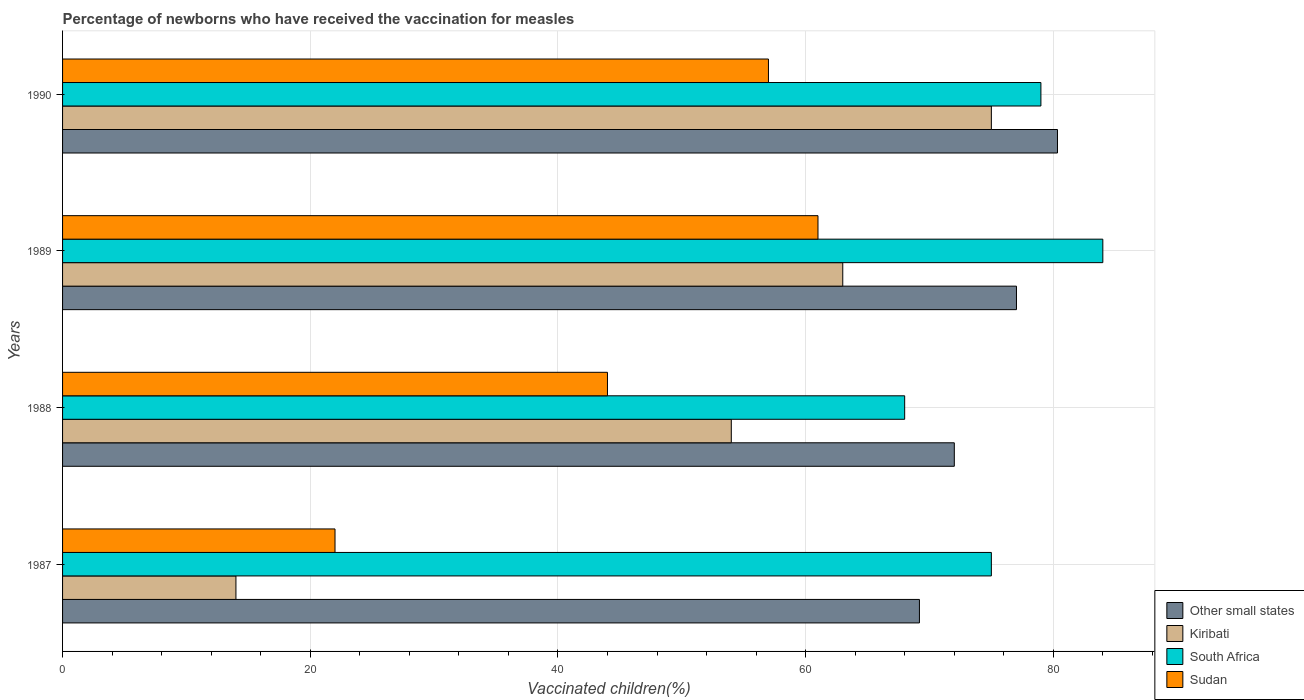How many different coloured bars are there?
Provide a short and direct response. 4. How many groups of bars are there?
Ensure brevity in your answer.  4. Are the number of bars per tick equal to the number of legend labels?
Ensure brevity in your answer.  Yes. Are the number of bars on each tick of the Y-axis equal?
Provide a short and direct response. Yes. How many bars are there on the 4th tick from the top?
Your answer should be compact. 4. How many bars are there on the 3rd tick from the bottom?
Your answer should be compact. 4. In how many cases, is the number of bars for a given year not equal to the number of legend labels?
Give a very brief answer. 0. In which year was the percentage of vaccinated children in Kiribati maximum?
Make the answer very short. 1990. In which year was the percentage of vaccinated children in Sudan minimum?
Your answer should be compact. 1987. What is the total percentage of vaccinated children in South Africa in the graph?
Ensure brevity in your answer.  306. What is the difference between the percentage of vaccinated children in Other small states in 1989 and that in 1990?
Your answer should be compact. -3.31. What is the difference between the percentage of vaccinated children in Kiribati in 1990 and the percentage of vaccinated children in Other small states in 1989?
Your response must be concise. -2.03. What is the ratio of the percentage of vaccinated children in Kiribati in 1987 to that in 1988?
Keep it short and to the point. 0.26. Is the difference between the percentage of vaccinated children in Sudan in 1988 and 1990 greater than the difference between the percentage of vaccinated children in South Africa in 1988 and 1990?
Make the answer very short. No. In how many years, is the percentage of vaccinated children in Other small states greater than the average percentage of vaccinated children in Other small states taken over all years?
Ensure brevity in your answer.  2. Is the sum of the percentage of vaccinated children in Other small states in 1989 and 1990 greater than the maximum percentage of vaccinated children in Kiribati across all years?
Provide a short and direct response. Yes. Is it the case that in every year, the sum of the percentage of vaccinated children in Kiribati and percentage of vaccinated children in Sudan is greater than the sum of percentage of vaccinated children in South Africa and percentage of vaccinated children in Other small states?
Your answer should be very brief. No. What does the 2nd bar from the top in 1990 represents?
Make the answer very short. South Africa. What does the 4th bar from the bottom in 1989 represents?
Your answer should be very brief. Sudan. Is it the case that in every year, the sum of the percentage of vaccinated children in Sudan and percentage of vaccinated children in Kiribati is greater than the percentage of vaccinated children in Other small states?
Your response must be concise. No. How many years are there in the graph?
Provide a succinct answer. 4. What is the difference between two consecutive major ticks on the X-axis?
Provide a short and direct response. 20. Are the values on the major ticks of X-axis written in scientific E-notation?
Your answer should be compact. No. Does the graph contain any zero values?
Your answer should be very brief. No. Does the graph contain grids?
Offer a very short reply. Yes. Where does the legend appear in the graph?
Provide a succinct answer. Bottom right. How many legend labels are there?
Keep it short and to the point. 4. What is the title of the graph?
Provide a succinct answer. Percentage of newborns who have received the vaccination for measles. What is the label or title of the X-axis?
Offer a very short reply. Vaccinated children(%). What is the label or title of the Y-axis?
Offer a terse response. Years. What is the Vaccinated children(%) of Other small states in 1987?
Keep it short and to the point. 69.19. What is the Vaccinated children(%) of Sudan in 1987?
Offer a terse response. 22. What is the Vaccinated children(%) in Other small states in 1988?
Offer a very short reply. 72.01. What is the Vaccinated children(%) in Kiribati in 1988?
Offer a terse response. 54. What is the Vaccinated children(%) in South Africa in 1988?
Provide a succinct answer. 68. What is the Vaccinated children(%) in Sudan in 1988?
Offer a terse response. 44. What is the Vaccinated children(%) in Other small states in 1989?
Make the answer very short. 77.03. What is the Vaccinated children(%) of South Africa in 1989?
Your response must be concise. 84. What is the Vaccinated children(%) of Sudan in 1989?
Provide a succinct answer. 61. What is the Vaccinated children(%) of Other small states in 1990?
Keep it short and to the point. 80.34. What is the Vaccinated children(%) of Kiribati in 1990?
Offer a very short reply. 75. What is the Vaccinated children(%) of South Africa in 1990?
Provide a succinct answer. 79. What is the Vaccinated children(%) in Sudan in 1990?
Provide a succinct answer. 57. Across all years, what is the maximum Vaccinated children(%) of Other small states?
Keep it short and to the point. 80.34. Across all years, what is the minimum Vaccinated children(%) in Other small states?
Offer a terse response. 69.19. Across all years, what is the minimum Vaccinated children(%) of Kiribati?
Ensure brevity in your answer.  14. Across all years, what is the minimum Vaccinated children(%) in South Africa?
Offer a very short reply. 68. What is the total Vaccinated children(%) of Other small states in the graph?
Provide a short and direct response. 298.57. What is the total Vaccinated children(%) in Kiribati in the graph?
Offer a terse response. 206. What is the total Vaccinated children(%) of South Africa in the graph?
Offer a terse response. 306. What is the total Vaccinated children(%) in Sudan in the graph?
Offer a very short reply. 184. What is the difference between the Vaccinated children(%) in Other small states in 1987 and that in 1988?
Your response must be concise. -2.82. What is the difference between the Vaccinated children(%) in Other small states in 1987 and that in 1989?
Keep it short and to the point. -7.84. What is the difference between the Vaccinated children(%) in Kiribati in 1987 and that in 1989?
Your answer should be compact. -49. What is the difference between the Vaccinated children(%) of South Africa in 1987 and that in 1989?
Give a very brief answer. -9. What is the difference between the Vaccinated children(%) in Sudan in 1987 and that in 1989?
Provide a short and direct response. -39. What is the difference between the Vaccinated children(%) of Other small states in 1987 and that in 1990?
Your answer should be very brief. -11.15. What is the difference between the Vaccinated children(%) of Kiribati in 1987 and that in 1990?
Offer a very short reply. -61. What is the difference between the Vaccinated children(%) of South Africa in 1987 and that in 1990?
Ensure brevity in your answer.  -4. What is the difference between the Vaccinated children(%) in Sudan in 1987 and that in 1990?
Your answer should be very brief. -35. What is the difference between the Vaccinated children(%) of Other small states in 1988 and that in 1989?
Your answer should be very brief. -5.02. What is the difference between the Vaccinated children(%) of Sudan in 1988 and that in 1989?
Provide a succinct answer. -17. What is the difference between the Vaccinated children(%) in Other small states in 1988 and that in 1990?
Ensure brevity in your answer.  -8.33. What is the difference between the Vaccinated children(%) in Kiribati in 1988 and that in 1990?
Offer a terse response. -21. What is the difference between the Vaccinated children(%) of South Africa in 1988 and that in 1990?
Ensure brevity in your answer.  -11. What is the difference between the Vaccinated children(%) in Other small states in 1989 and that in 1990?
Your answer should be compact. -3.31. What is the difference between the Vaccinated children(%) in South Africa in 1989 and that in 1990?
Offer a terse response. 5. What is the difference between the Vaccinated children(%) of Other small states in 1987 and the Vaccinated children(%) of Kiribati in 1988?
Make the answer very short. 15.19. What is the difference between the Vaccinated children(%) in Other small states in 1987 and the Vaccinated children(%) in South Africa in 1988?
Give a very brief answer. 1.19. What is the difference between the Vaccinated children(%) in Other small states in 1987 and the Vaccinated children(%) in Sudan in 1988?
Keep it short and to the point. 25.19. What is the difference between the Vaccinated children(%) of Kiribati in 1987 and the Vaccinated children(%) of South Africa in 1988?
Offer a very short reply. -54. What is the difference between the Vaccinated children(%) of Kiribati in 1987 and the Vaccinated children(%) of Sudan in 1988?
Your response must be concise. -30. What is the difference between the Vaccinated children(%) in South Africa in 1987 and the Vaccinated children(%) in Sudan in 1988?
Ensure brevity in your answer.  31. What is the difference between the Vaccinated children(%) in Other small states in 1987 and the Vaccinated children(%) in Kiribati in 1989?
Ensure brevity in your answer.  6.19. What is the difference between the Vaccinated children(%) in Other small states in 1987 and the Vaccinated children(%) in South Africa in 1989?
Ensure brevity in your answer.  -14.81. What is the difference between the Vaccinated children(%) of Other small states in 1987 and the Vaccinated children(%) of Sudan in 1989?
Provide a succinct answer. 8.19. What is the difference between the Vaccinated children(%) in Kiribati in 1987 and the Vaccinated children(%) in South Africa in 1989?
Your response must be concise. -70. What is the difference between the Vaccinated children(%) of Kiribati in 1987 and the Vaccinated children(%) of Sudan in 1989?
Provide a succinct answer. -47. What is the difference between the Vaccinated children(%) in South Africa in 1987 and the Vaccinated children(%) in Sudan in 1989?
Ensure brevity in your answer.  14. What is the difference between the Vaccinated children(%) of Other small states in 1987 and the Vaccinated children(%) of Kiribati in 1990?
Your answer should be very brief. -5.81. What is the difference between the Vaccinated children(%) of Other small states in 1987 and the Vaccinated children(%) of South Africa in 1990?
Offer a terse response. -9.81. What is the difference between the Vaccinated children(%) of Other small states in 1987 and the Vaccinated children(%) of Sudan in 1990?
Make the answer very short. 12.19. What is the difference between the Vaccinated children(%) in Kiribati in 1987 and the Vaccinated children(%) in South Africa in 1990?
Make the answer very short. -65. What is the difference between the Vaccinated children(%) in Kiribati in 1987 and the Vaccinated children(%) in Sudan in 1990?
Keep it short and to the point. -43. What is the difference between the Vaccinated children(%) in Other small states in 1988 and the Vaccinated children(%) in Kiribati in 1989?
Provide a short and direct response. 9.01. What is the difference between the Vaccinated children(%) in Other small states in 1988 and the Vaccinated children(%) in South Africa in 1989?
Your answer should be compact. -11.99. What is the difference between the Vaccinated children(%) of Other small states in 1988 and the Vaccinated children(%) of Sudan in 1989?
Make the answer very short. 11.01. What is the difference between the Vaccinated children(%) in Kiribati in 1988 and the Vaccinated children(%) in South Africa in 1989?
Provide a short and direct response. -30. What is the difference between the Vaccinated children(%) of Kiribati in 1988 and the Vaccinated children(%) of Sudan in 1989?
Offer a very short reply. -7. What is the difference between the Vaccinated children(%) of South Africa in 1988 and the Vaccinated children(%) of Sudan in 1989?
Give a very brief answer. 7. What is the difference between the Vaccinated children(%) in Other small states in 1988 and the Vaccinated children(%) in Kiribati in 1990?
Give a very brief answer. -2.99. What is the difference between the Vaccinated children(%) in Other small states in 1988 and the Vaccinated children(%) in South Africa in 1990?
Provide a succinct answer. -6.99. What is the difference between the Vaccinated children(%) in Other small states in 1988 and the Vaccinated children(%) in Sudan in 1990?
Provide a succinct answer. 15.01. What is the difference between the Vaccinated children(%) of South Africa in 1988 and the Vaccinated children(%) of Sudan in 1990?
Ensure brevity in your answer.  11. What is the difference between the Vaccinated children(%) of Other small states in 1989 and the Vaccinated children(%) of Kiribati in 1990?
Offer a very short reply. 2.03. What is the difference between the Vaccinated children(%) of Other small states in 1989 and the Vaccinated children(%) of South Africa in 1990?
Provide a short and direct response. -1.97. What is the difference between the Vaccinated children(%) in Other small states in 1989 and the Vaccinated children(%) in Sudan in 1990?
Make the answer very short. 20.03. What is the difference between the Vaccinated children(%) of Kiribati in 1989 and the Vaccinated children(%) of South Africa in 1990?
Provide a succinct answer. -16. What is the average Vaccinated children(%) in Other small states per year?
Ensure brevity in your answer.  74.64. What is the average Vaccinated children(%) of Kiribati per year?
Offer a very short reply. 51.5. What is the average Vaccinated children(%) of South Africa per year?
Make the answer very short. 76.5. In the year 1987, what is the difference between the Vaccinated children(%) in Other small states and Vaccinated children(%) in Kiribati?
Keep it short and to the point. 55.19. In the year 1987, what is the difference between the Vaccinated children(%) in Other small states and Vaccinated children(%) in South Africa?
Give a very brief answer. -5.81. In the year 1987, what is the difference between the Vaccinated children(%) of Other small states and Vaccinated children(%) of Sudan?
Your response must be concise. 47.19. In the year 1987, what is the difference between the Vaccinated children(%) of Kiribati and Vaccinated children(%) of South Africa?
Offer a very short reply. -61. In the year 1988, what is the difference between the Vaccinated children(%) in Other small states and Vaccinated children(%) in Kiribati?
Offer a terse response. 18.01. In the year 1988, what is the difference between the Vaccinated children(%) in Other small states and Vaccinated children(%) in South Africa?
Your answer should be compact. 4.01. In the year 1988, what is the difference between the Vaccinated children(%) of Other small states and Vaccinated children(%) of Sudan?
Offer a terse response. 28.01. In the year 1989, what is the difference between the Vaccinated children(%) in Other small states and Vaccinated children(%) in Kiribati?
Ensure brevity in your answer.  14.03. In the year 1989, what is the difference between the Vaccinated children(%) of Other small states and Vaccinated children(%) of South Africa?
Provide a short and direct response. -6.97. In the year 1989, what is the difference between the Vaccinated children(%) in Other small states and Vaccinated children(%) in Sudan?
Give a very brief answer. 16.03. In the year 1989, what is the difference between the Vaccinated children(%) in Kiribati and Vaccinated children(%) in Sudan?
Keep it short and to the point. 2. In the year 1990, what is the difference between the Vaccinated children(%) in Other small states and Vaccinated children(%) in Kiribati?
Your answer should be compact. 5.34. In the year 1990, what is the difference between the Vaccinated children(%) in Other small states and Vaccinated children(%) in South Africa?
Your response must be concise. 1.34. In the year 1990, what is the difference between the Vaccinated children(%) of Other small states and Vaccinated children(%) of Sudan?
Provide a short and direct response. 23.34. In the year 1990, what is the difference between the Vaccinated children(%) of Kiribati and Vaccinated children(%) of Sudan?
Give a very brief answer. 18. What is the ratio of the Vaccinated children(%) of Other small states in 1987 to that in 1988?
Offer a terse response. 0.96. What is the ratio of the Vaccinated children(%) of Kiribati in 1987 to that in 1988?
Give a very brief answer. 0.26. What is the ratio of the Vaccinated children(%) in South Africa in 1987 to that in 1988?
Your answer should be very brief. 1.1. What is the ratio of the Vaccinated children(%) of Sudan in 1987 to that in 1988?
Provide a succinct answer. 0.5. What is the ratio of the Vaccinated children(%) of Other small states in 1987 to that in 1989?
Your response must be concise. 0.9. What is the ratio of the Vaccinated children(%) in Kiribati in 1987 to that in 1989?
Your response must be concise. 0.22. What is the ratio of the Vaccinated children(%) of South Africa in 1987 to that in 1989?
Give a very brief answer. 0.89. What is the ratio of the Vaccinated children(%) of Sudan in 1987 to that in 1989?
Offer a terse response. 0.36. What is the ratio of the Vaccinated children(%) of Other small states in 1987 to that in 1990?
Offer a very short reply. 0.86. What is the ratio of the Vaccinated children(%) of Kiribati in 1987 to that in 1990?
Your answer should be very brief. 0.19. What is the ratio of the Vaccinated children(%) of South Africa in 1987 to that in 1990?
Make the answer very short. 0.95. What is the ratio of the Vaccinated children(%) of Sudan in 1987 to that in 1990?
Your answer should be very brief. 0.39. What is the ratio of the Vaccinated children(%) in Other small states in 1988 to that in 1989?
Provide a short and direct response. 0.93. What is the ratio of the Vaccinated children(%) in Kiribati in 1988 to that in 1989?
Make the answer very short. 0.86. What is the ratio of the Vaccinated children(%) of South Africa in 1988 to that in 1989?
Your response must be concise. 0.81. What is the ratio of the Vaccinated children(%) in Sudan in 1988 to that in 1989?
Offer a terse response. 0.72. What is the ratio of the Vaccinated children(%) of Other small states in 1988 to that in 1990?
Keep it short and to the point. 0.9. What is the ratio of the Vaccinated children(%) of Kiribati in 1988 to that in 1990?
Your response must be concise. 0.72. What is the ratio of the Vaccinated children(%) in South Africa in 1988 to that in 1990?
Your answer should be compact. 0.86. What is the ratio of the Vaccinated children(%) of Sudan in 1988 to that in 1990?
Make the answer very short. 0.77. What is the ratio of the Vaccinated children(%) in Other small states in 1989 to that in 1990?
Provide a short and direct response. 0.96. What is the ratio of the Vaccinated children(%) of Kiribati in 1989 to that in 1990?
Offer a very short reply. 0.84. What is the ratio of the Vaccinated children(%) in South Africa in 1989 to that in 1990?
Make the answer very short. 1.06. What is the ratio of the Vaccinated children(%) of Sudan in 1989 to that in 1990?
Keep it short and to the point. 1.07. What is the difference between the highest and the second highest Vaccinated children(%) in Other small states?
Provide a succinct answer. 3.31. What is the difference between the highest and the second highest Vaccinated children(%) in Kiribati?
Keep it short and to the point. 12. What is the difference between the highest and the lowest Vaccinated children(%) in Other small states?
Offer a very short reply. 11.15. What is the difference between the highest and the lowest Vaccinated children(%) of Kiribati?
Your answer should be very brief. 61. What is the difference between the highest and the lowest Vaccinated children(%) of South Africa?
Keep it short and to the point. 16. What is the difference between the highest and the lowest Vaccinated children(%) in Sudan?
Your answer should be compact. 39. 